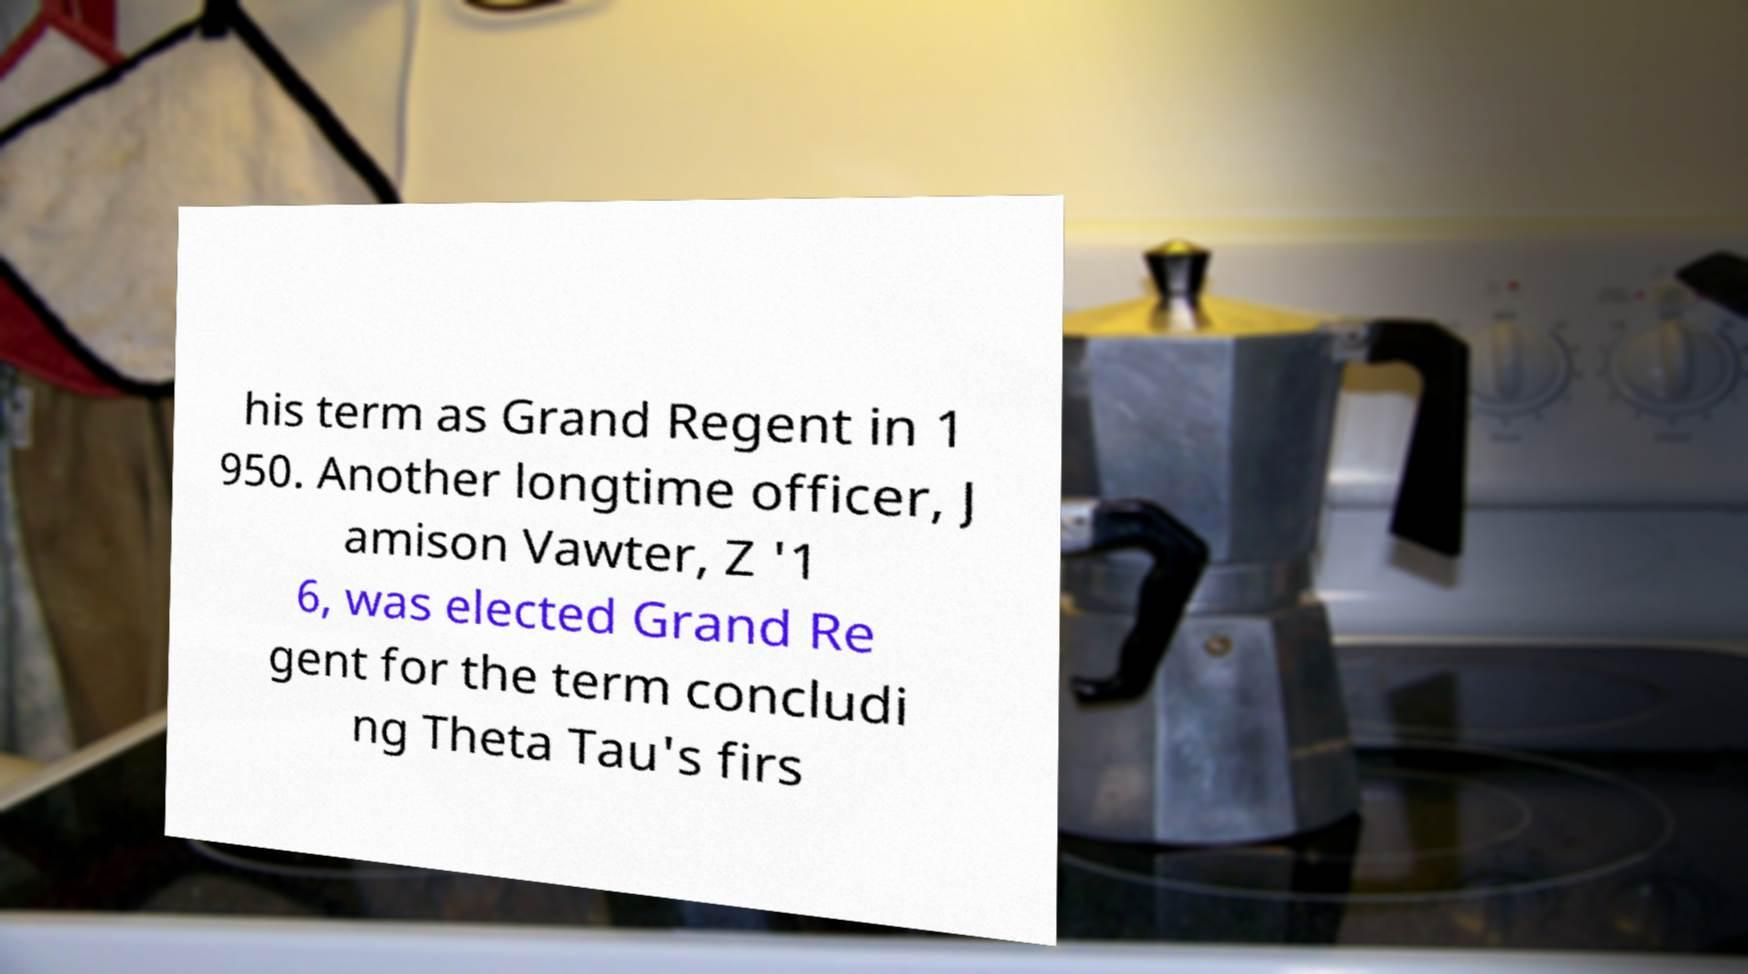Could you assist in decoding the text presented in this image and type it out clearly? his term as Grand Regent in 1 950. Another longtime officer, J amison Vawter, Z '1 6, was elected Grand Re gent for the term concludi ng Theta Tau's firs 